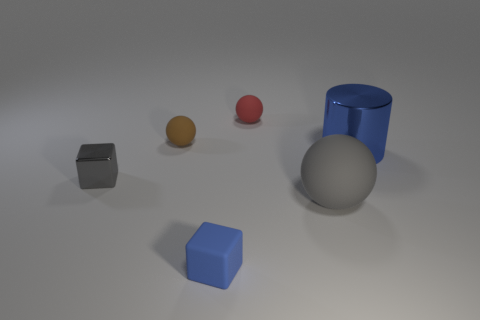Add 3 blue balls. How many objects exist? 9 Subtract all blocks. How many objects are left? 4 Add 6 gray rubber objects. How many gray rubber objects are left? 7 Add 4 spheres. How many spheres exist? 7 Subtract 0 yellow cylinders. How many objects are left? 6 Subtract all small rubber cubes. Subtract all red spheres. How many objects are left? 4 